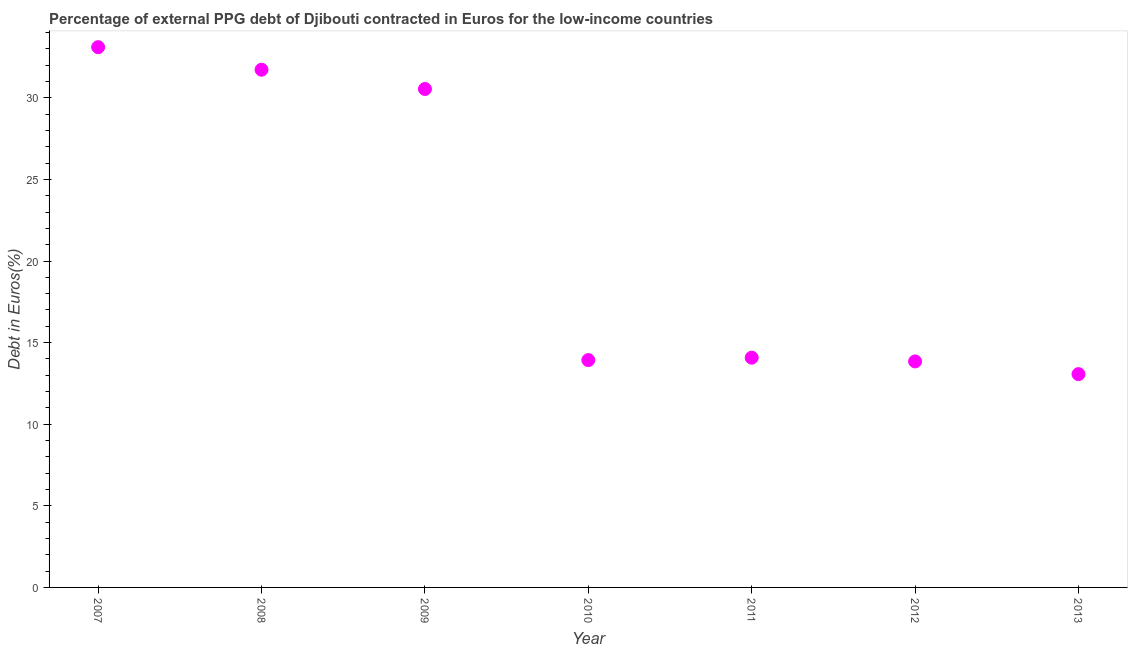What is the currency composition of ppg debt in 2010?
Provide a succinct answer. 13.93. Across all years, what is the maximum currency composition of ppg debt?
Give a very brief answer. 33.1. Across all years, what is the minimum currency composition of ppg debt?
Your answer should be compact. 13.07. In which year was the currency composition of ppg debt maximum?
Provide a succinct answer. 2007. What is the sum of the currency composition of ppg debt?
Your answer should be compact. 150.28. What is the difference between the currency composition of ppg debt in 2012 and 2013?
Your response must be concise. 0.78. What is the average currency composition of ppg debt per year?
Give a very brief answer. 21.47. What is the median currency composition of ppg debt?
Make the answer very short. 14.08. In how many years, is the currency composition of ppg debt greater than 8 %?
Provide a short and direct response. 7. What is the ratio of the currency composition of ppg debt in 2007 to that in 2012?
Keep it short and to the point. 2.39. Is the difference between the currency composition of ppg debt in 2012 and 2013 greater than the difference between any two years?
Your response must be concise. No. What is the difference between the highest and the second highest currency composition of ppg debt?
Your response must be concise. 1.38. Is the sum of the currency composition of ppg debt in 2009 and 2011 greater than the maximum currency composition of ppg debt across all years?
Your answer should be compact. Yes. What is the difference between the highest and the lowest currency composition of ppg debt?
Provide a short and direct response. 20.03. In how many years, is the currency composition of ppg debt greater than the average currency composition of ppg debt taken over all years?
Make the answer very short. 3. Does the currency composition of ppg debt monotonically increase over the years?
Make the answer very short. No. How many years are there in the graph?
Provide a succinct answer. 7. What is the difference between two consecutive major ticks on the Y-axis?
Provide a succinct answer. 5. Does the graph contain grids?
Provide a short and direct response. No. What is the title of the graph?
Give a very brief answer. Percentage of external PPG debt of Djibouti contracted in Euros for the low-income countries. What is the label or title of the Y-axis?
Keep it short and to the point. Debt in Euros(%). What is the Debt in Euros(%) in 2007?
Ensure brevity in your answer.  33.1. What is the Debt in Euros(%) in 2008?
Make the answer very short. 31.72. What is the Debt in Euros(%) in 2009?
Offer a very short reply. 30.54. What is the Debt in Euros(%) in 2010?
Your answer should be compact. 13.93. What is the Debt in Euros(%) in 2011?
Offer a terse response. 14.08. What is the Debt in Euros(%) in 2012?
Make the answer very short. 13.85. What is the Debt in Euros(%) in 2013?
Your response must be concise. 13.07. What is the difference between the Debt in Euros(%) in 2007 and 2008?
Your answer should be compact. 1.38. What is the difference between the Debt in Euros(%) in 2007 and 2009?
Provide a short and direct response. 2.56. What is the difference between the Debt in Euros(%) in 2007 and 2010?
Your answer should be compact. 19.17. What is the difference between the Debt in Euros(%) in 2007 and 2011?
Your answer should be very brief. 19.03. What is the difference between the Debt in Euros(%) in 2007 and 2012?
Ensure brevity in your answer.  19.25. What is the difference between the Debt in Euros(%) in 2007 and 2013?
Provide a short and direct response. 20.03. What is the difference between the Debt in Euros(%) in 2008 and 2009?
Offer a terse response. 1.18. What is the difference between the Debt in Euros(%) in 2008 and 2010?
Offer a very short reply. 17.79. What is the difference between the Debt in Euros(%) in 2008 and 2011?
Provide a succinct answer. 17.64. What is the difference between the Debt in Euros(%) in 2008 and 2012?
Provide a short and direct response. 17.87. What is the difference between the Debt in Euros(%) in 2008 and 2013?
Give a very brief answer. 18.65. What is the difference between the Debt in Euros(%) in 2009 and 2010?
Give a very brief answer. 16.61. What is the difference between the Debt in Euros(%) in 2009 and 2011?
Make the answer very short. 16.46. What is the difference between the Debt in Euros(%) in 2009 and 2012?
Make the answer very short. 16.69. What is the difference between the Debt in Euros(%) in 2009 and 2013?
Make the answer very short. 17.47. What is the difference between the Debt in Euros(%) in 2010 and 2011?
Offer a terse response. -0.15. What is the difference between the Debt in Euros(%) in 2010 and 2012?
Your answer should be compact. 0.08. What is the difference between the Debt in Euros(%) in 2010 and 2013?
Your response must be concise. 0.86. What is the difference between the Debt in Euros(%) in 2011 and 2012?
Offer a terse response. 0.23. What is the difference between the Debt in Euros(%) in 2012 and 2013?
Your answer should be compact. 0.78. What is the ratio of the Debt in Euros(%) in 2007 to that in 2008?
Give a very brief answer. 1.04. What is the ratio of the Debt in Euros(%) in 2007 to that in 2009?
Offer a very short reply. 1.08. What is the ratio of the Debt in Euros(%) in 2007 to that in 2010?
Give a very brief answer. 2.38. What is the ratio of the Debt in Euros(%) in 2007 to that in 2011?
Provide a succinct answer. 2.35. What is the ratio of the Debt in Euros(%) in 2007 to that in 2012?
Make the answer very short. 2.39. What is the ratio of the Debt in Euros(%) in 2007 to that in 2013?
Your answer should be compact. 2.53. What is the ratio of the Debt in Euros(%) in 2008 to that in 2009?
Offer a very short reply. 1.04. What is the ratio of the Debt in Euros(%) in 2008 to that in 2010?
Provide a short and direct response. 2.28. What is the ratio of the Debt in Euros(%) in 2008 to that in 2011?
Your answer should be compact. 2.25. What is the ratio of the Debt in Euros(%) in 2008 to that in 2012?
Offer a very short reply. 2.29. What is the ratio of the Debt in Euros(%) in 2008 to that in 2013?
Offer a very short reply. 2.43. What is the ratio of the Debt in Euros(%) in 2009 to that in 2010?
Make the answer very short. 2.19. What is the ratio of the Debt in Euros(%) in 2009 to that in 2011?
Offer a terse response. 2.17. What is the ratio of the Debt in Euros(%) in 2009 to that in 2012?
Ensure brevity in your answer.  2.21. What is the ratio of the Debt in Euros(%) in 2009 to that in 2013?
Keep it short and to the point. 2.34. What is the ratio of the Debt in Euros(%) in 2010 to that in 2013?
Provide a short and direct response. 1.07. What is the ratio of the Debt in Euros(%) in 2011 to that in 2012?
Make the answer very short. 1.02. What is the ratio of the Debt in Euros(%) in 2011 to that in 2013?
Ensure brevity in your answer.  1.08. What is the ratio of the Debt in Euros(%) in 2012 to that in 2013?
Ensure brevity in your answer.  1.06. 